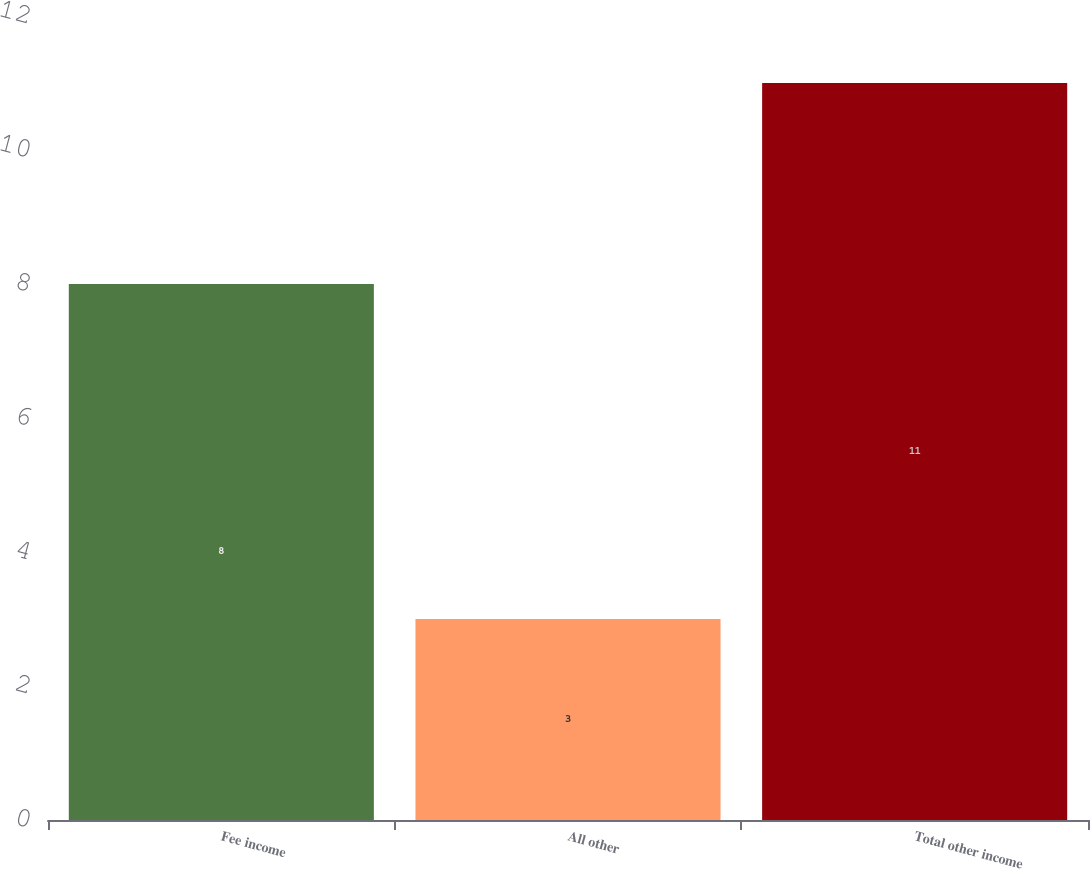<chart> <loc_0><loc_0><loc_500><loc_500><bar_chart><fcel>Fee income<fcel>All other<fcel>Total other income<nl><fcel>8<fcel>3<fcel>11<nl></chart> 